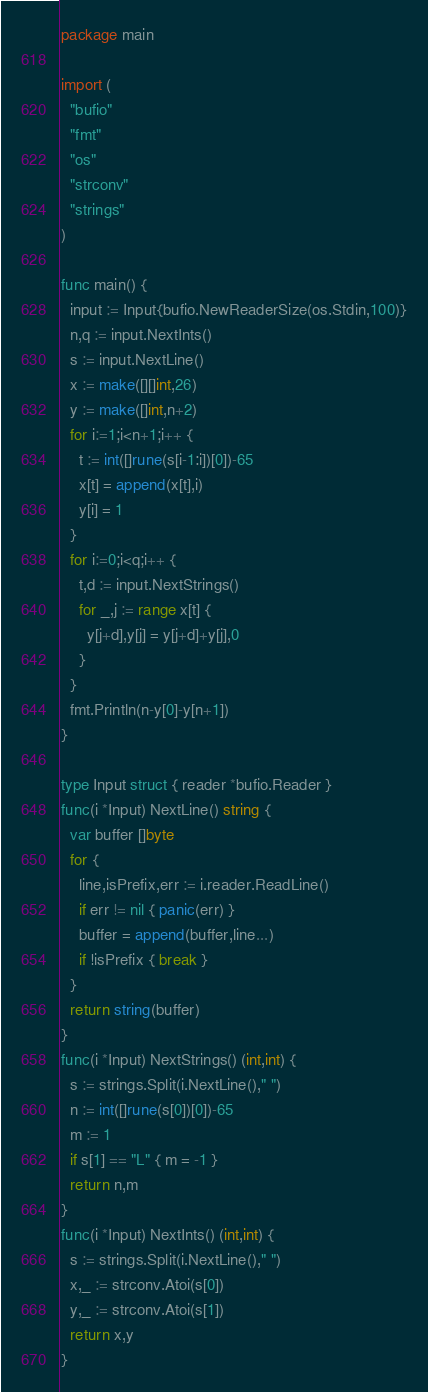<code> <loc_0><loc_0><loc_500><loc_500><_Go_>package main

import (
  "bufio"
  "fmt"
  "os"
  "strconv"
  "strings"
)

func main() {
  input := Input{bufio.NewReaderSize(os.Stdin,100)}
  n,q := input.NextInts()
  s := input.NextLine()
  x := make([][]int,26)
  y := make([]int,n+2)
  for i:=1;i<n+1;i++ {
    t := int([]rune(s[i-1:i])[0])-65
    x[t] = append(x[t],i)
    y[i] = 1
  }
  for i:=0;i<q;i++ {
    t,d := input.NextStrings()
    for _,j := range x[t] {
      y[j+d],y[j] = y[j+d]+y[j],0
    }
  }
  fmt.Println(n-y[0]-y[n+1])
}

type Input struct { reader *bufio.Reader }
func(i *Input) NextLine() string {
  var buffer []byte
  for {
    line,isPrefix,err := i.reader.ReadLine()
    if err != nil { panic(err) }
    buffer = append(buffer,line...)
    if !isPrefix { break }
  }
  return string(buffer)
}
func(i *Input) NextStrings() (int,int) {
  s := strings.Split(i.NextLine()," ")
  n := int([]rune(s[0])[0])-65
  m := 1
  if s[1] == "L" { m = -1 }
  return n,m
}
func(i *Input) NextInts() (int,int) {
  s := strings.Split(i.NextLine()," ")
  x,_ := strconv.Atoi(s[0])
  y,_ := strconv.Atoi(s[1])
  return x,y
}</code> 